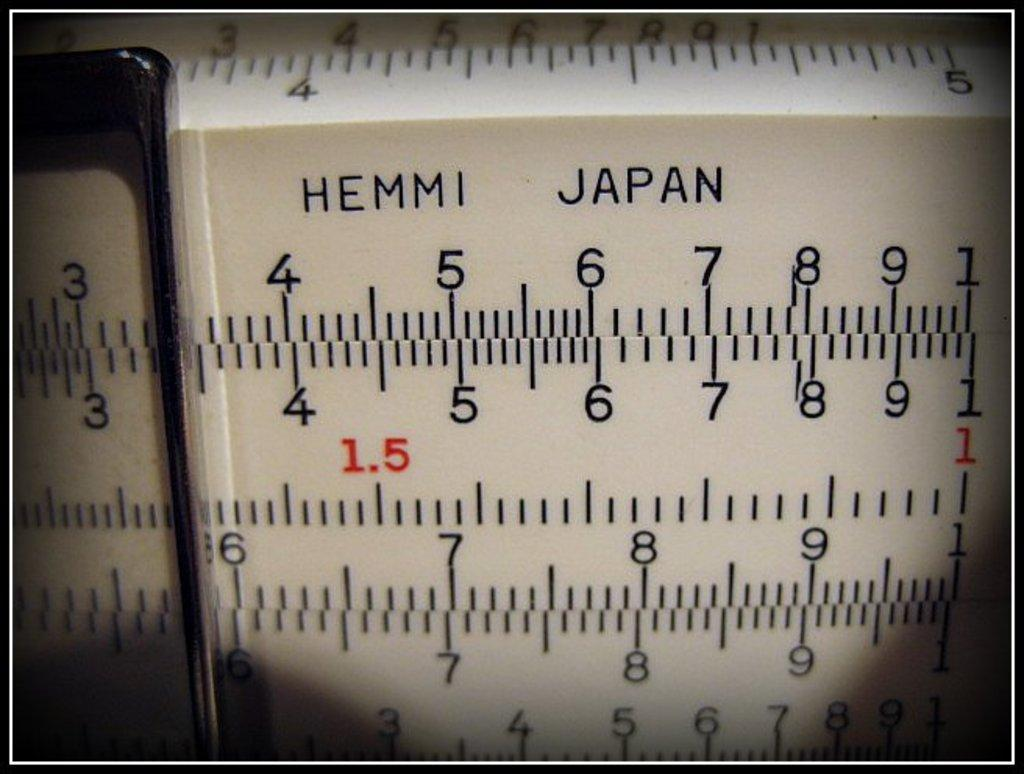<image>
Write a terse but informative summary of the picture. A measuring device labeled Hemmi Japan with a slider positioned around the number 3. 